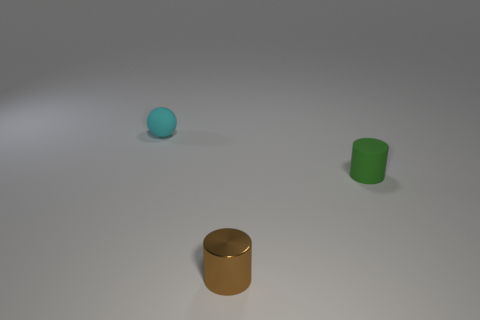The green thing that is made of the same material as the ball is what shape?
Provide a short and direct response. Cylinder. What shape is the matte object to the right of the thing behind the tiny rubber thing that is on the right side of the tiny matte ball?
Make the answer very short. Cylinder. Is the number of brown cylinders greater than the number of large gray metal things?
Offer a very short reply. Yes. There is a tiny brown object that is the same shape as the green object; what is it made of?
Offer a terse response. Metal. Is the small green thing made of the same material as the brown object?
Ensure brevity in your answer.  No. Are there more tiny cyan rubber balls behind the metallic object than tiny brown rubber blocks?
Ensure brevity in your answer.  Yes. What material is the tiny thing that is behind the tiny matte object that is right of the tiny thing left of the metal thing made of?
Give a very brief answer. Rubber. What number of objects are large brown cubes or tiny cylinders that are left of the green rubber object?
Keep it short and to the point. 1. Is the number of tiny cyan balls behind the tiny brown cylinder greater than the number of cyan spheres in front of the small cyan object?
Provide a succinct answer. Yes. Are there any other things of the same color as the metallic cylinder?
Give a very brief answer. No. 